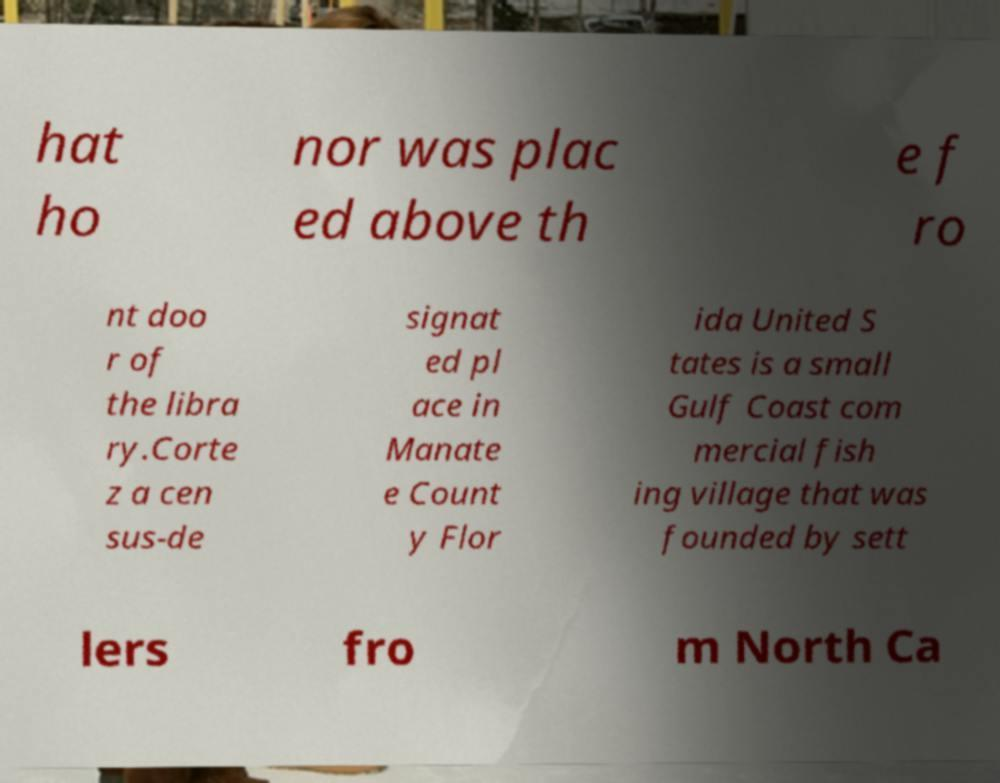Can you read and provide the text displayed in the image?This photo seems to have some interesting text. Can you extract and type it out for me? hat ho nor was plac ed above th e f ro nt doo r of the libra ry.Corte z a cen sus-de signat ed pl ace in Manate e Count y Flor ida United S tates is a small Gulf Coast com mercial fish ing village that was founded by sett lers fro m North Ca 